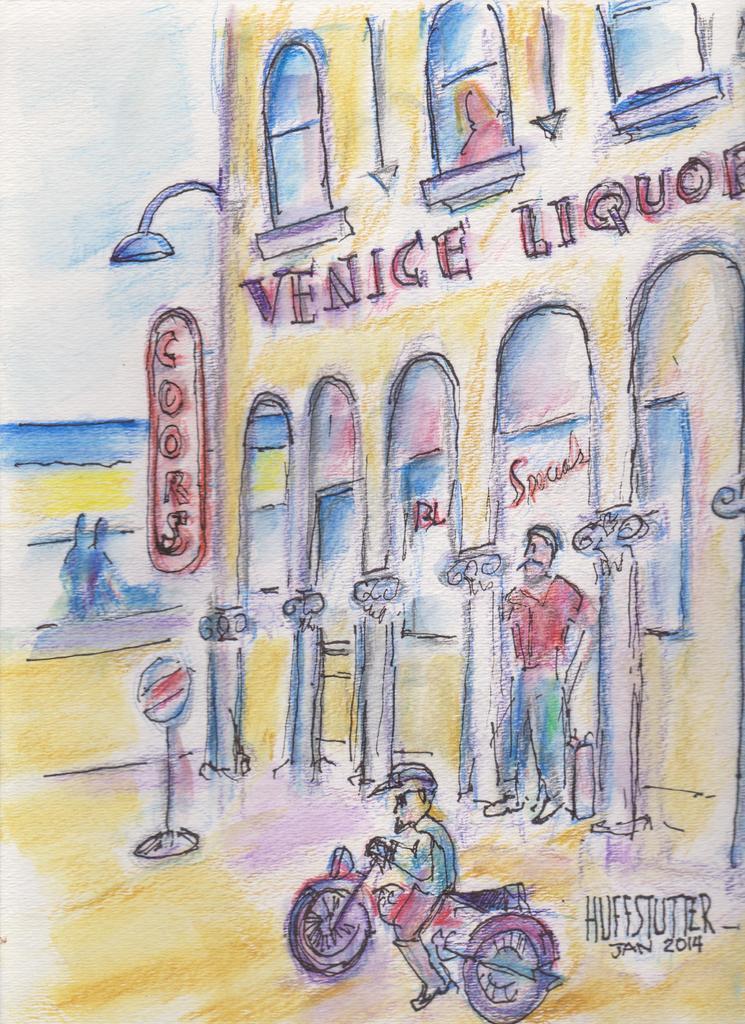Can you describe this image briefly? In this image I can see paintings of a house, windows, light pole, boards, person, bike, text, three peoples and the sky. 